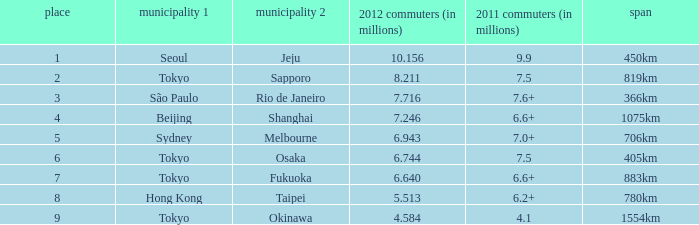In 2011, which city is listed first along the route that had 7.6+ million passengers? São Paulo. 